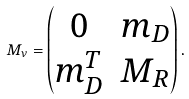<formula> <loc_0><loc_0><loc_500><loc_500>M _ { \nu } = \begin{pmatrix} 0 & m _ { D } \\ m _ { D } ^ { T } & M _ { R } \end{pmatrix} .</formula> 